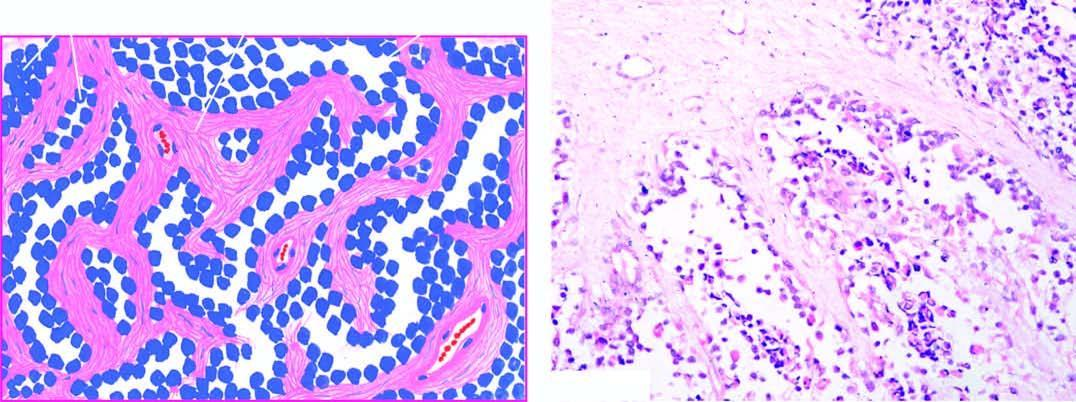s dermoid cyst divided into alveolar spaces composed of fibrocollagenous tissue?
Answer the question using a single word or phrase. No 